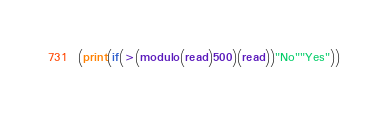<code> <loc_0><loc_0><loc_500><loc_500><_Scheme_>(print(if(>(modulo(read)500)(read))"No""Yes"))</code> 